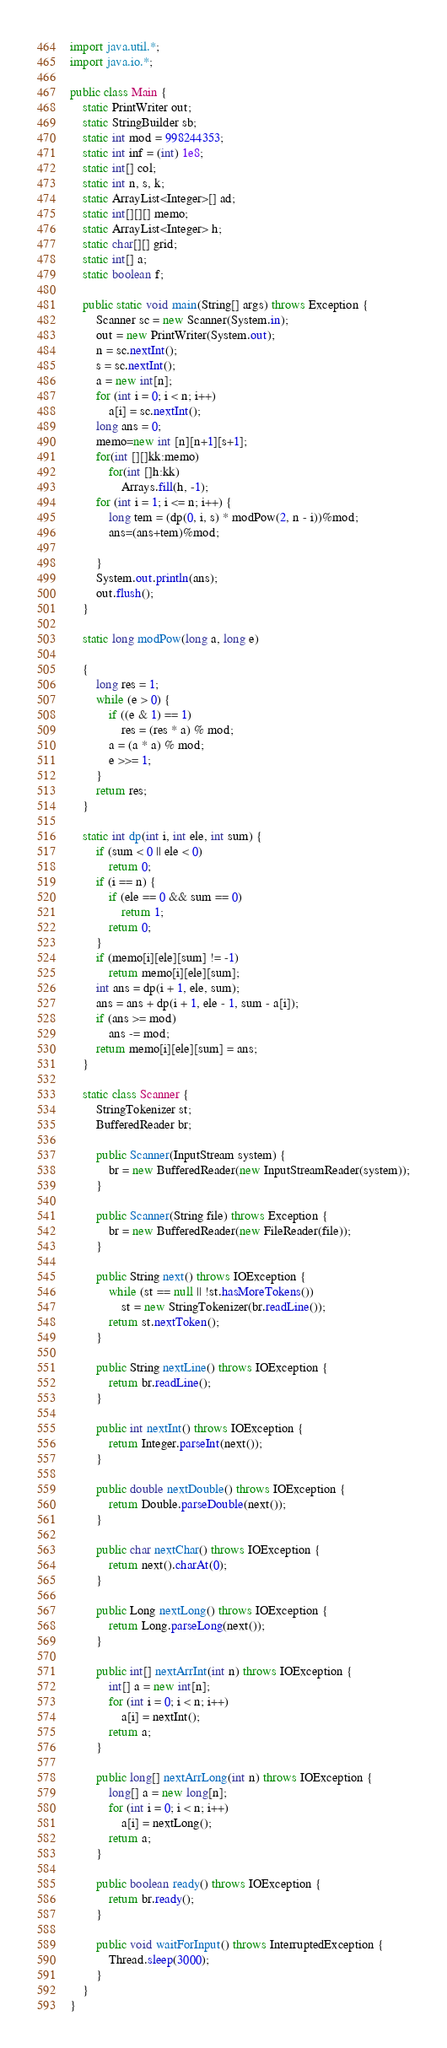Convert code to text. <code><loc_0><loc_0><loc_500><loc_500><_Java_>import java.util.*;
import java.io.*;

public class Main {
	static PrintWriter out;
	static StringBuilder sb;
	static int mod = 998244353;
	static int inf = (int) 1e8;
	static int[] col;
	static int n, s, k;
	static ArrayList<Integer>[] ad;
	static int[][][] memo;
	static ArrayList<Integer> h;
	static char[][] grid;
	static int[] a;
	static boolean f;

	public static void main(String[] args) throws Exception {
		Scanner sc = new Scanner(System.in);
		out = new PrintWriter(System.out);
		n = sc.nextInt();
		s = sc.nextInt();
		a = new int[n];
		for (int i = 0; i < n; i++)
			a[i] = sc.nextInt();
		long ans = 0;
		memo=new int [n][n+1][s+1];
		for(int [][]kk:memo)
			for(int []h:kk)
				Arrays.fill(h, -1);
		for (int i = 1; i <= n; i++) {
			long tem = (dp(0, i, s) * modPow(2, n - i))%mod;
			ans=(ans+tem)%mod;

		}
		System.out.println(ans);
		out.flush();
	}

	static long modPow(long a, long e)

	{
		long res = 1;
		while (e > 0) {
			if ((e & 1) == 1)
				res = (res * a) % mod;
			a = (a * a) % mod;
			e >>= 1;
		}
		return res;
	}

	static int dp(int i, int ele, int sum) {
		if (sum < 0 || ele < 0)
			return 0;
		if (i == n) {
			if (ele == 0 && sum == 0)
				return 1;
			return 0;
		}
		if (memo[i][ele][sum] != -1)
			return memo[i][ele][sum];
		int ans = dp(i + 1, ele, sum);
		ans = ans + dp(i + 1, ele - 1, sum - a[i]);
		if (ans >= mod)
			ans -= mod;
		return memo[i][ele][sum] = ans;
	}

	static class Scanner {
		StringTokenizer st;
		BufferedReader br;

		public Scanner(InputStream system) {
			br = new BufferedReader(new InputStreamReader(system));
		}

		public Scanner(String file) throws Exception {
			br = new BufferedReader(new FileReader(file));
		}

		public String next() throws IOException {
			while (st == null || !st.hasMoreTokens())
				st = new StringTokenizer(br.readLine());
			return st.nextToken();
		}

		public String nextLine() throws IOException {
			return br.readLine();
		}

		public int nextInt() throws IOException {
			return Integer.parseInt(next());
		}

		public double nextDouble() throws IOException {
			return Double.parseDouble(next());
		}

		public char nextChar() throws IOException {
			return next().charAt(0);
		}

		public Long nextLong() throws IOException {
			return Long.parseLong(next());
		}

		public int[] nextArrInt(int n) throws IOException {
			int[] a = new int[n];
			for (int i = 0; i < n; i++)
				a[i] = nextInt();
			return a;
		}

		public long[] nextArrLong(int n) throws IOException {
			long[] a = new long[n];
			for (int i = 0; i < n; i++)
				a[i] = nextLong();
			return a;
		}

		public boolean ready() throws IOException {
			return br.ready();
		}

		public void waitForInput() throws InterruptedException {
			Thread.sleep(3000);
		}
	}
}</code> 